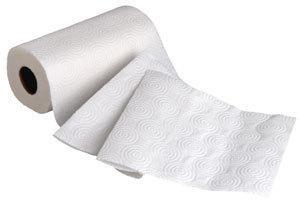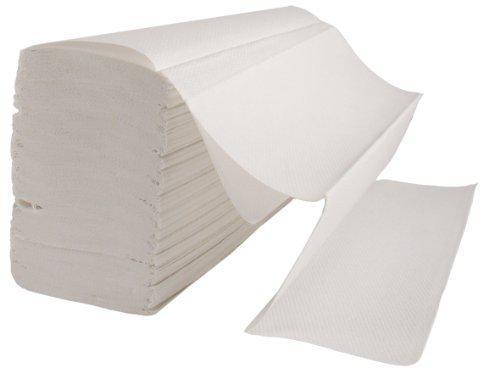The first image is the image on the left, the second image is the image on the right. Assess this claim about the two images: "There are no less than three rolls of paper towels in the image on the left.". Correct or not? Answer yes or no. No. The first image is the image on the left, the second image is the image on the right. Assess this claim about the two images: "One roll of paper towels is brown and at least three are white.". Correct or not? Answer yes or no. No. 